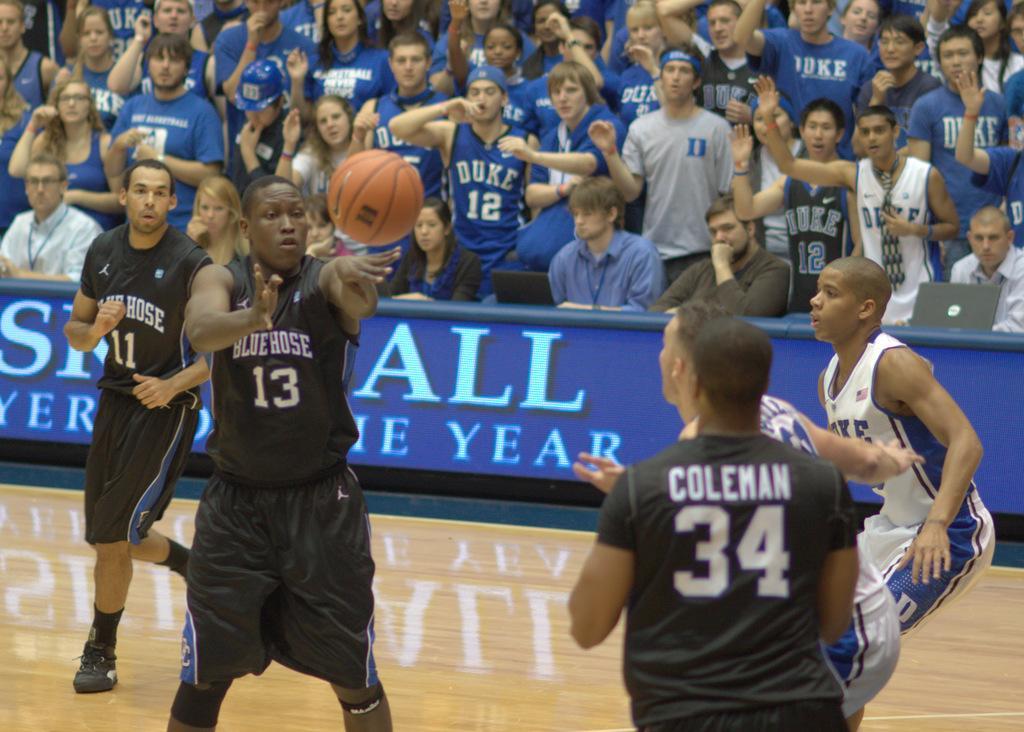How would you summarize this image in a sentence or two? In this image I can see group of people playing game. In front the person is wearing black color dress and I can also see the ball in brown color. In the background I can see the board in blue color and I can also see group of people, some are sitting and some are standing. 